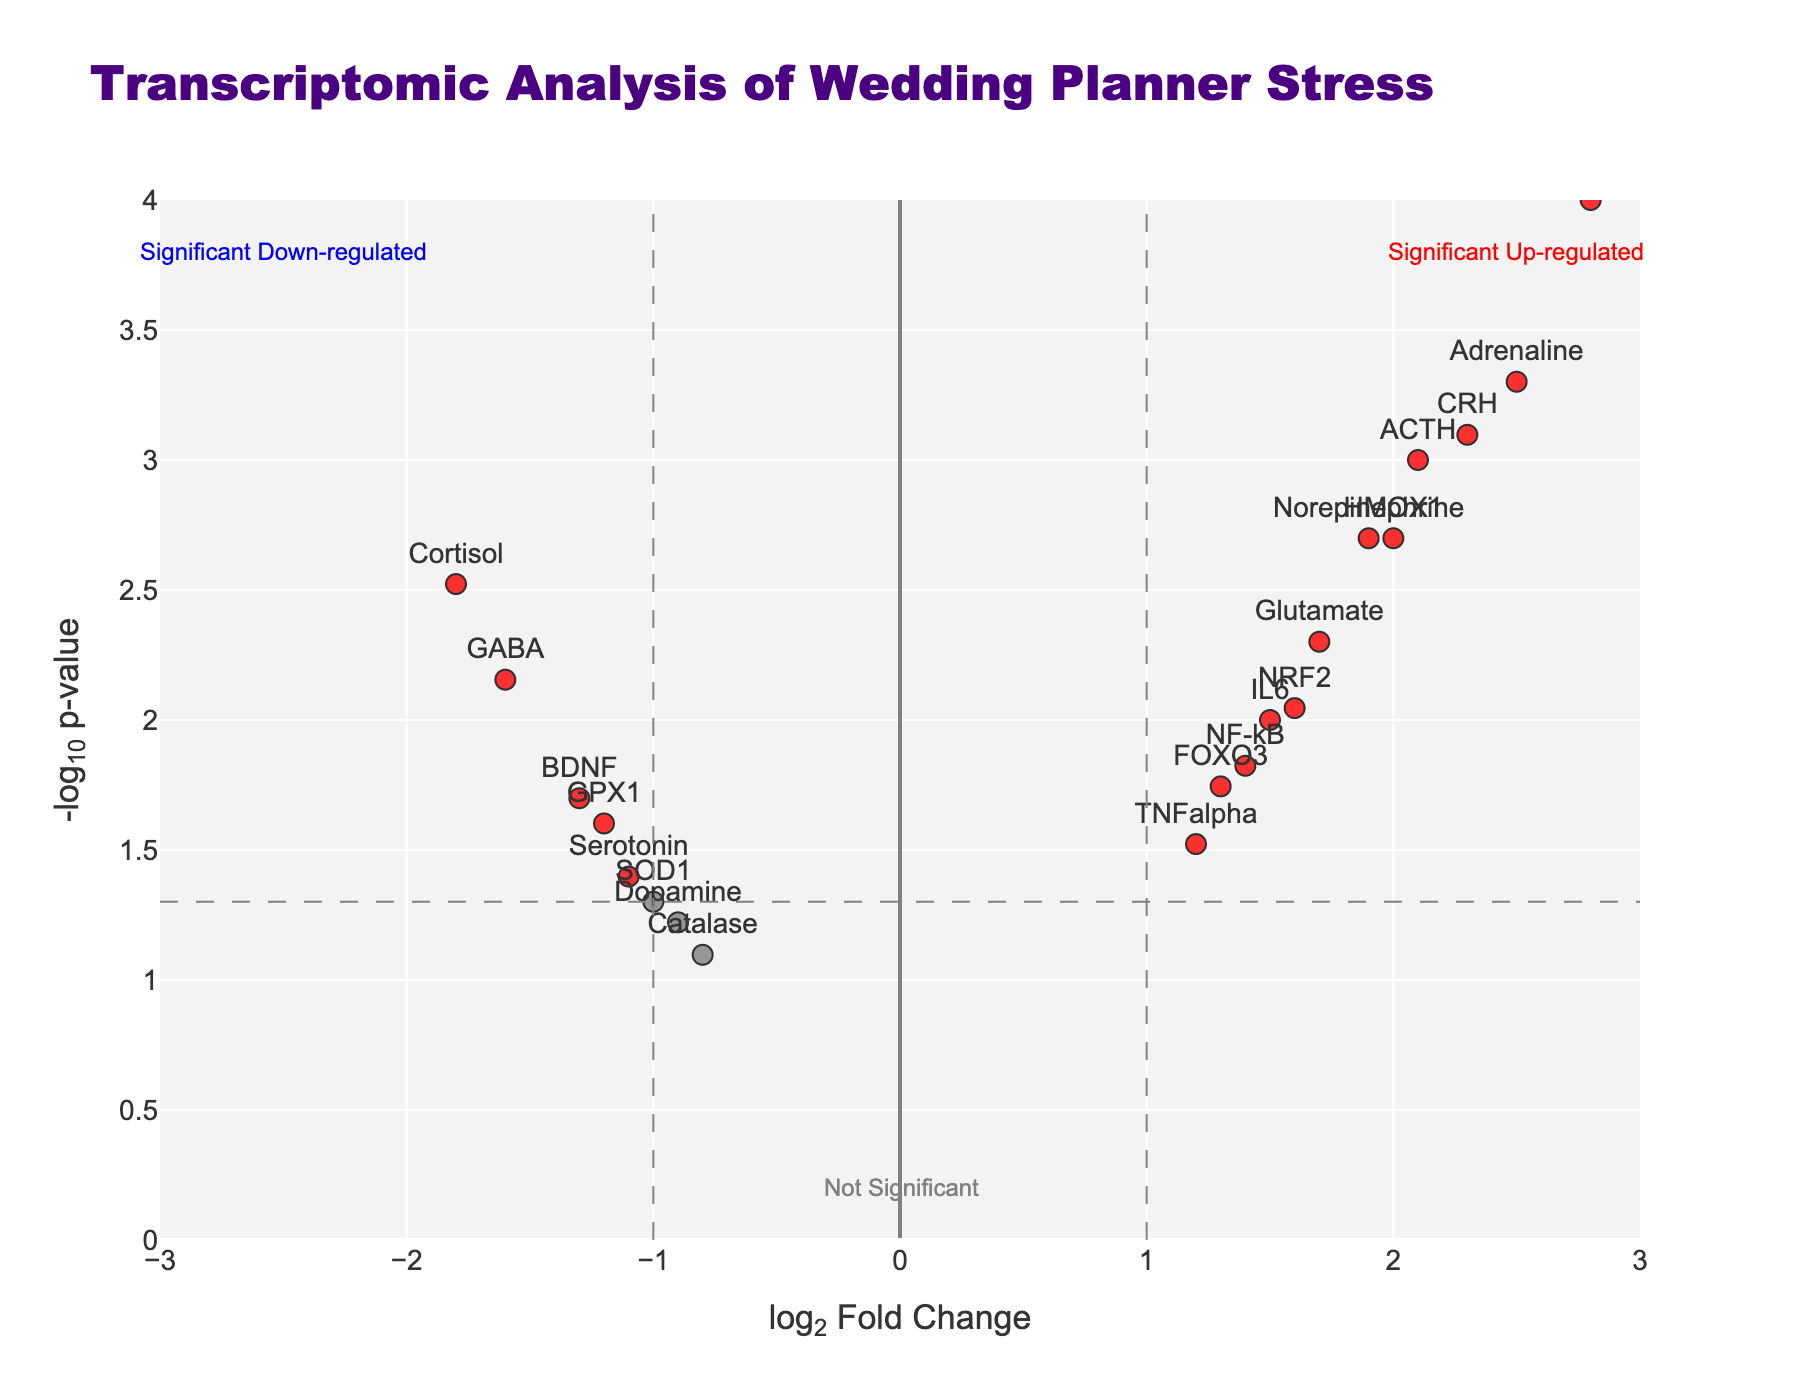What's the title of the figure? The title is displayed at the top of the figure. Looking at the figure, the title reads "Transcriptomic Analysis of Wedding Planner Stress".
Answer: Transcriptomic Analysis of Wedding Planner Stress How many genes are marked in red? The red markers represent genes with significant up-regulation. By counting the red points in the figure, we find there are six red markers.
Answer: Six Which gene has the highest log2 fold change? By checking the x-axis for the gene with the highest positive value, HSP70 shows the highest log2 fold change at 2.8.
Answer: HSP70 Which gene has the lowest p-value? The y-axis represents -log10(p-value), meaning the highest point corresponds to the lowest p-value. HSP70 is the highest point on the y-axis, indicating it has the lowest p-value.
Answer: HSP70 Identify a gene that is neither significantly up-regulated nor down-regulated. Genes not significantly regulated are marked in grey. By checking the marker colors, "Dopamine" (grey marker) fits this category.
Answer: Dopamine How many genes have a log2 fold change greater than 2 but less than 2.5? Genes with log2 fold changes in this range can be visually identified between 2 and 2.5 on the x-axis. The genes "ACTH (2.1)" and "CRH (2.3)" fall within this range.
Answer: Two Which gene is significantly down-regulated and also has a -log10(p-value) above 2.5? Significant down-regulated genes are marked in blue, and those with -log10(p-value) greater than 2.5 will be above this y-axis value. "GABA" fits both criteria.
Answer: GABA What color represents genes with significant p-values but low log2 fold changes? By examining the explained categorization, blue markers represent genes with significant p-values but log2 fold changes within ±1.
Answer: Blue Which gene is closest to the intersection of the thresholds for significant log2 fold change and p-value? The intersection is at ±1 log2 fold change and -log10(0.05). "IL6," slightly above the y-axis threshold and near the log2 threshold, is closest.
Answer: IL6 